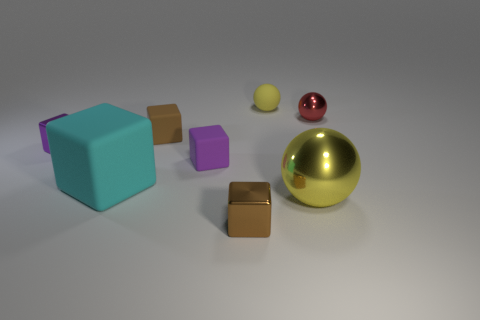Subtract 1 blocks. How many blocks are left? 4 Subtract all cyan blocks. How many blocks are left? 4 Subtract all green cubes. Subtract all cyan cylinders. How many cubes are left? 5 Add 1 tiny balls. How many objects exist? 9 Subtract all balls. How many objects are left? 5 Add 7 big objects. How many big objects are left? 9 Add 8 small yellow things. How many small yellow things exist? 9 Subtract 0 red blocks. How many objects are left? 8 Subtract all small brown metallic cubes. Subtract all tiny purple rubber blocks. How many objects are left? 6 